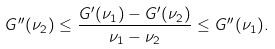<formula> <loc_0><loc_0><loc_500><loc_500>G ^ { \prime \prime } ( \nu _ { 2 } ) \leq \frac { G ^ { \prime } ( \nu _ { 1 } ) - G ^ { \prime } ( \nu _ { 2 } ) } { \nu _ { 1 } - \nu _ { 2 } } \leq G ^ { \prime \prime } ( \nu _ { 1 } ) .</formula> 